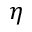<formula> <loc_0><loc_0><loc_500><loc_500>\eta</formula> 